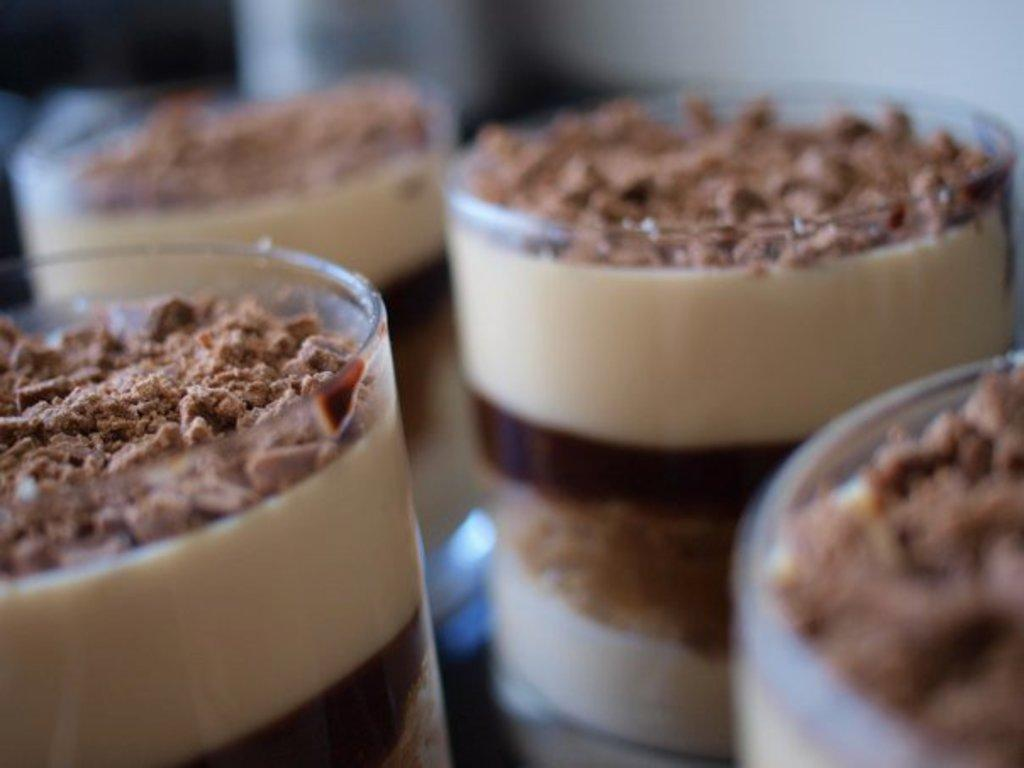What objects are in the center of the image? There are glasses in the center of the image. What is inside the glasses? The glasses contain black forest chocolate forest chocolate coffee. Can you describe the background of the image? The background of the image is blurred. What type of cloud can be seen in the image? There is no cloud present in the image; it features glasses containing black forest chocolate coffee with a blurred background. 